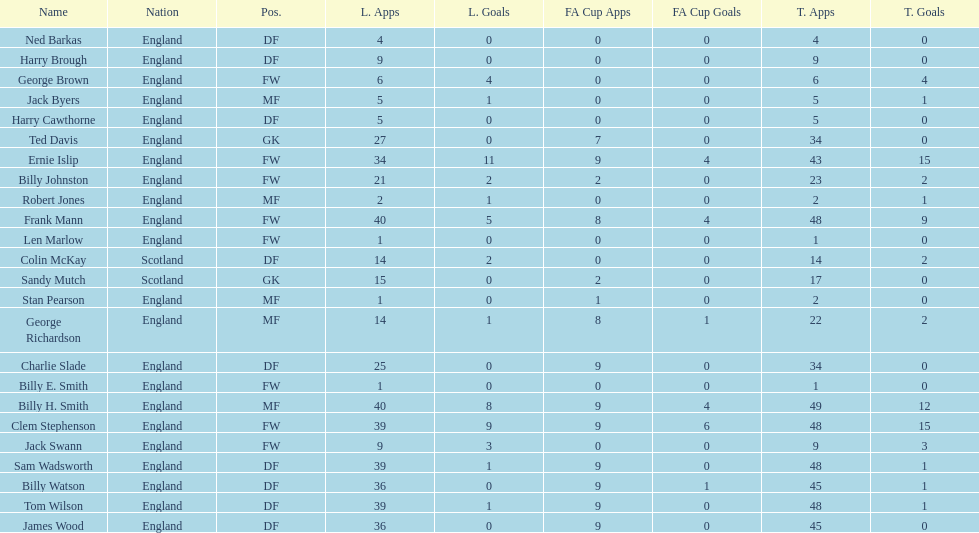Could you parse the entire table as a dict? {'header': ['Name', 'Nation', 'Pos.', 'L. Apps', 'L. Goals', 'FA Cup Apps', 'FA Cup Goals', 'T. Apps', 'T. Goals'], 'rows': [['Ned Barkas', 'England', 'DF', '4', '0', '0', '0', '4', '0'], ['Harry Brough', 'England', 'DF', '9', '0', '0', '0', '9', '0'], ['George Brown', 'England', 'FW', '6', '4', '0', '0', '6', '4'], ['Jack Byers', 'England', 'MF', '5', '1', '0', '0', '5', '1'], ['Harry Cawthorne', 'England', 'DF', '5', '0', '0', '0', '5', '0'], ['Ted Davis', 'England', 'GK', '27', '0', '7', '0', '34', '0'], ['Ernie Islip', 'England', 'FW', '34', '11', '9', '4', '43', '15'], ['Billy Johnston', 'England', 'FW', '21', '2', '2', '0', '23', '2'], ['Robert Jones', 'England', 'MF', '2', '1', '0', '0', '2', '1'], ['Frank Mann', 'England', 'FW', '40', '5', '8', '4', '48', '9'], ['Len Marlow', 'England', 'FW', '1', '0', '0', '0', '1', '0'], ['Colin McKay', 'Scotland', 'DF', '14', '2', '0', '0', '14', '2'], ['Sandy Mutch', 'Scotland', 'GK', '15', '0', '2', '0', '17', '0'], ['Stan Pearson', 'England', 'MF', '1', '0', '1', '0', '2', '0'], ['George Richardson', 'England', 'MF', '14', '1', '8', '1', '22', '2'], ['Charlie Slade', 'England', 'DF', '25', '0', '9', '0', '34', '0'], ['Billy E. Smith', 'England', 'FW', '1', '0', '0', '0', '1', '0'], ['Billy H. Smith', 'England', 'MF', '40', '8', '9', '4', '49', '12'], ['Clem Stephenson', 'England', 'FW', '39', '9', '9', '6', '48', '15'], ['Jack Swann', 'England', 'FW', '9', '3', '0', '0', '9', '3'], ['Sam Wadsworth', 'England', 'DF', '39', '1', '9', '0', '48', '1'], ['Billy Watson', 'England', 'DF', '36', '0', '9', '1', '45', '1'], ['Tom Wilson', 'England', 'DF', '39', '1', '9', '0', '48', '1'], ['James Wood', 'England', 'DF', '36', '0', '9', '0', '45', '0']]} How many league applications does ted davis have? 27. 